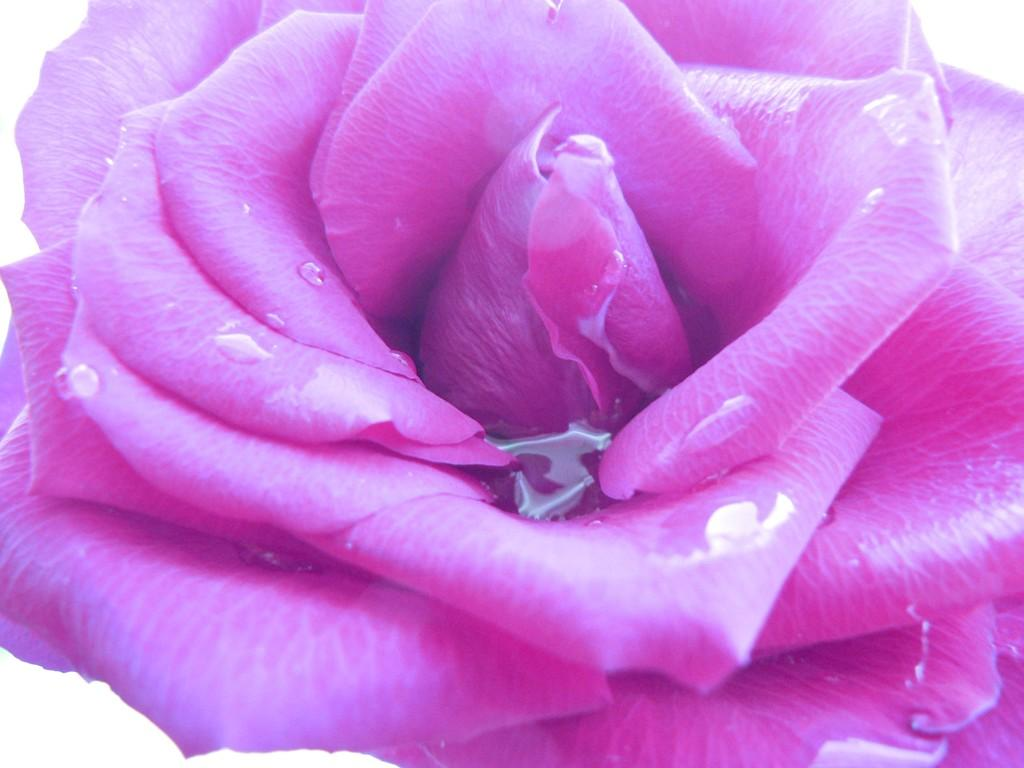What type of flower is in the image? There is a pink rose flower in the image. Can you describe the condition of the pink rose flower? The pink rose flower has water drops on it. What color is the background of the image? The background of the image is white. Is the engine in the image running quietly? There is no engine present in the image; it features a pink rose flower with water drops on it against a white background. 